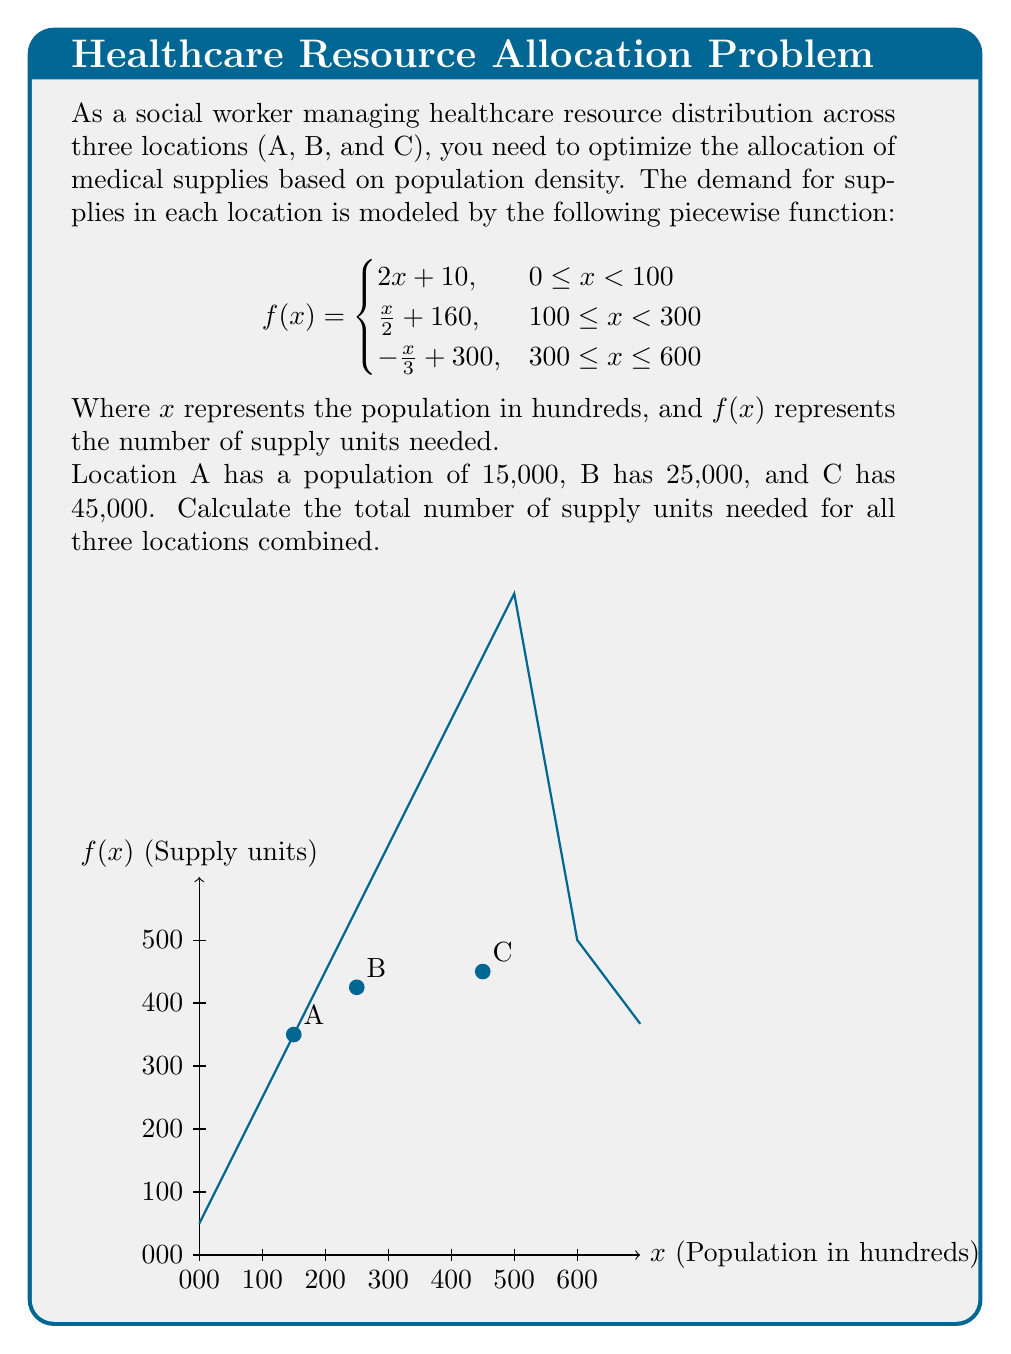Solve this math problem. Let's approach this step-by-step:

1) First, we need to determine which piece of the function to use for each location:

   A: 15,000 people = 150 hundreds, falls in the range 100 ≤ x < 300
   B: 25,000 people = 250 hundreds, falls in the range 100 ≤ x < 300
   C: 45,000 people = 450 hundreds, falls in the range 300 ≤ x ≤ 600

2) Now, let's calculate the supply units needed for each location:

   For A: $f(150) = \frac{150}{2} + 160 = 75 + 160 = 235$ units

   For B: $f(250) = \frac{250}{2} + 160 = 125 + 160 = 285$ units

   For C: $f(450) = -\frac{450}{3} + 300 = -150 + 300 = 150$ units

3) Finally, we sum up the supply units for all three locations:

   Total supply units = 235 + 285 + 150 = 670 units

Therefore, the total number of supply units needed for all three locations combined is 670.
Answer: 670 units 